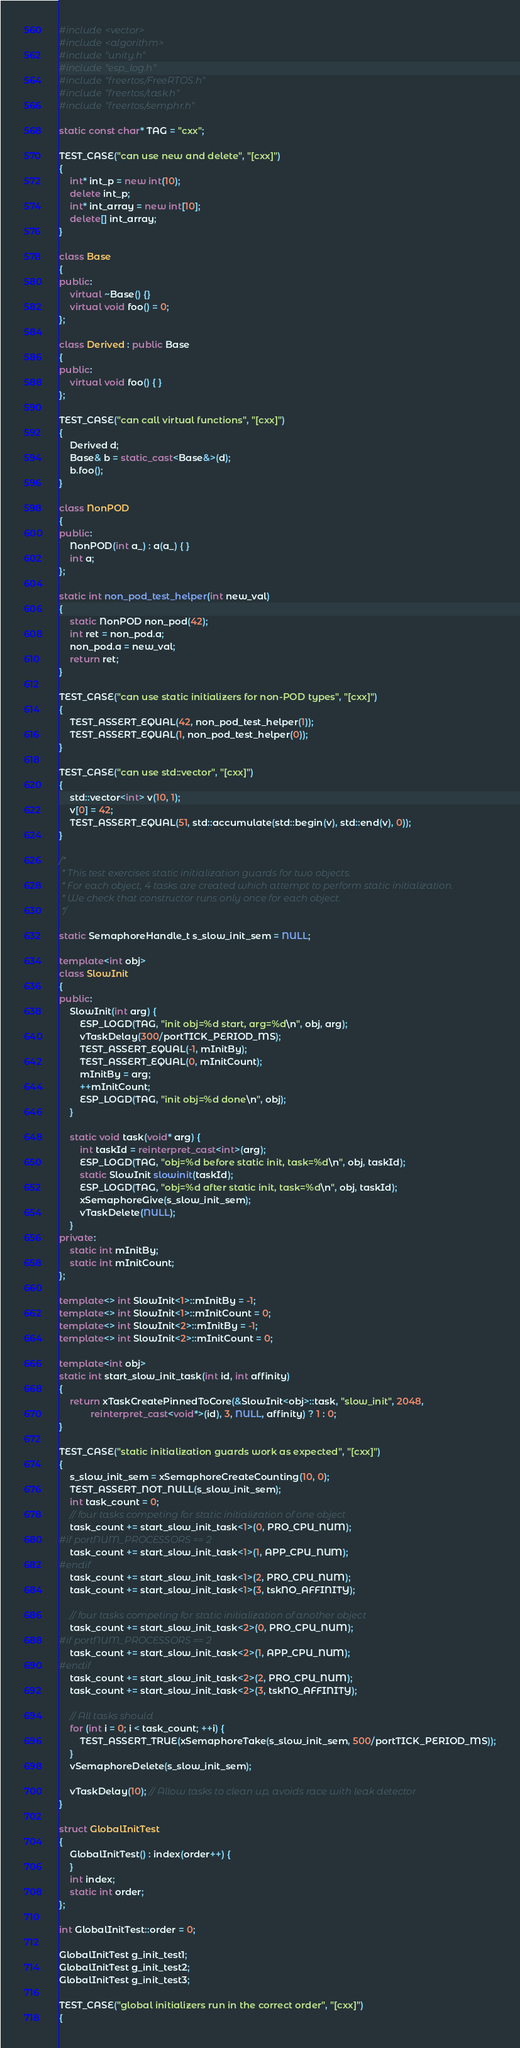<code> <loc_0><loc_0><loc_500><loc_500><_C++_>#include <vector>
#include <algorithm>
#include "unity.h"
#include "esp_log.h"
#include "freertos/FreeRTOS.h"
#include "freertos/task.h"
#include "freertos/semphr.h"

static const char* TAG = "cxx";

TEST_CASE("can use new and delete", "[cxx]")
{
    int* int_p = new int(10);
    delete int_p;
    int* int_array = new int[10];
    delete[] int_array;
}

class Base
{
public:
    virtual ~Base() {}
    virtual void foo() = 0;
};

class Derived : public Base
{
public:
    virtual void foo() { }
};

TEST_CASE("can call virtual functions", "[cxx]")
{
    Derived d;
    Base& b = static_cast<Base&>(d);
    b.foo();
}

class NonPOD
{
public:
    NonPOD(int a_) : a(a_) { }
    int a;
};

static int non_pod_test_helper(int new_val)
{
    static NonPOD non_pod(42);
    int ret = non_pod.a;
    non_pod.a = new_val;
    return ret;
}

TEST_CASE("can use static initializers for non-POD types", "[cxx]")
{
    TEST_ASSERT_EQUAL(42, non_pod_test_helper(1));
    TEST_ASSERT_EQUAL(1, non_pod_test_helper(0));
}

TEST_CASE("can use std::vector", "[cxx]")
{
    std::vector<int> v(10, 1);
    v[0] = 42;
    TEST_ASSERT_EQUAL(51, std::accumulate(std::begin(v), std::end(v), 0));
}

/*
 * This test exercises static initialization guards for two objects.
 * For each object, 4 tasks are created which attempt to perform static initialization.
 * We check that constructor runs only once for each object.
 */

static SemaphoreHandle_t s_slow_init_sem = NULL;

template<int obj>
class SlowInit
{
public:
    SlowInit(int arg) {
        ESP_LOGD(TAG, "init obj=%d start, arg=%d\n", obj, arg);
        vTaskDelay(300/portTICK_PERIOD_MS);
        TEST_ASSERT_EQUAL(-1, mInitBy);
        TEST_ASSERT_EQUAL(0, mInitCount);
        mInitBy = arg;
        ++mInitCount;
        ESP_LOGD(TAG, "init obj=%d done\n", obj);
    }

    static void task(void* arg) {
        int taskId = reinterpret_cast<int>(arg);
        ESP_LOGD(TAG, "obj=%d before static init, task=%d\n", obj, taskId);
        static SlowInit slowinit(taskId);
        ESP_LOGD(TAG, "obj=%d after static init, task=%d\n", obj, taskId);
        xSemaphoreGive(s_slow_init_sem);
        vTaskDelete(NULL);
    }
private:
    static int mInitBy;
    static int mInitCount;
};

template<> int SlowInit<1>::mInitBy = -1;
template<> int SlowInit<1>::mInitCount = 0;
template<> int SlowInit<2>::mInitBy = -1;
template<> int SlowInit<2>::mInitCount = 0;

template<int obj>
static int start_slow_init_task(int id, int affinity)
{
    return xTaskCreatePinnedToCore(&SlowInit<obj>::task, "slow_init", 2048,
            reinterpret_cast<void*>(id), 3, NULL, affinity) ? 1 : 0;
}

TEST_CASE("static initialization guards work as expected", "[cxx]")
{
    s_slow_init_sem = xSemaphoreCreateCounting(10, 0);
    TEST_ASSERT_NOT_NULL(s_slow_init_sem);
    int task_count = 0;
    // four tasks competing for static initialization of one object
    task_count += start_slow_init_task<1>(0, PRO_CPU_NUM);
#if portNUM_PROCESSORS == 2
    task_count += start_slow_init_task<1>(1, APP_CPU_NUM);
#endif
    task_count += start_slow_init_task<1>(2, PRO_CPU_NUM);
    task_count += start_slow_init_task<1>(3, tskNO_AFFINITY);

    // four tasks competing for static initialization of another object
    task_count += start_slow_init_task<2>(0, PRO_CPU_NUM);
#if portNUM_PROCESSORS == 2
    task_count += start_slow_init_task<2>(1, APP_CPU_NUM);
#endif
    task_count += start_slow_init_task<2>(2, PRO_CPU_NUM);
    task_count += start_slow_init_task<2>(3, tskNO_AFFINITY);

    // All tasks should
    for (int i = 0; i < task_count; ++i) {
        TEST_ASSERT_TRUE(xSemaphoreTake(s_slow_init_sem, 500/portTICK_PERIOD_MS));
    }
    vSemaphoreDelete(s_slow_init_sem);

    vTaskDelay(10); // Allow tasks to clean up, avoids race with leak detector
}

struct GlobalInitTest
{
    GlobalInitTest() : index(order++) {
    }
    int index;
    static int order;
};

int GlobalInitTest::order = 0;

GlobalInitTest g_init_test1;
GlobalInitTest g_init_test2;
GlobalInitTest g_init_test3;

TEST_CASE("global initializers run in the correct order", "[cxx]")
{</code> 